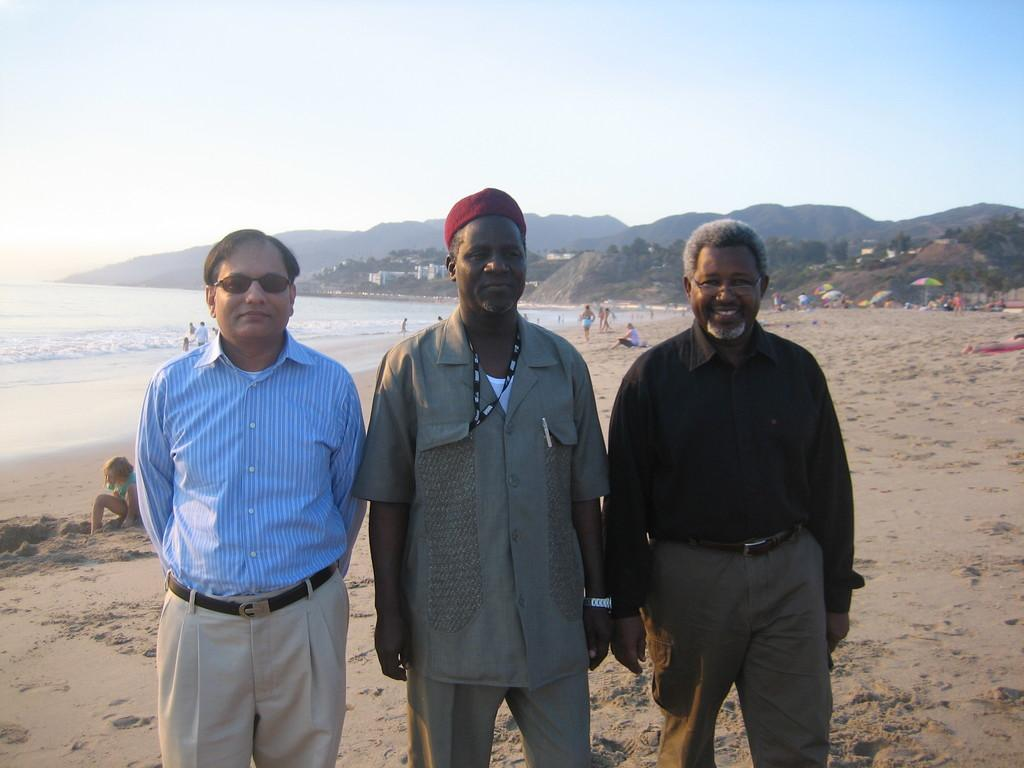What are the men in the image doing? The men in the image are standing on the seashore. What can be seen in the background of the image? In the background, there are people sitting and standing on the seashore, the sea, hills, buildings, parasols, and the sky. How many types of objects are present in the background? There are at least eight types of objects present in the background: people sitting and standing, the sea, hills, buildings, parasols, and the sky. What type of bubble can be seen floating near the men in the image? There is no bubble present in the image; it features men standing on the seashore and various elements in the background. 